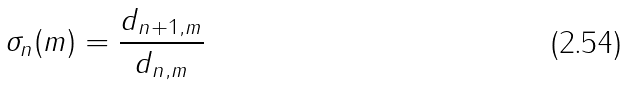Convert formula to latex. <formula><loc_0><loc_0><loc_500><loc_500>\sigma _ { n } ( m ) = \frac { d _ { n + 1 , m } } { d _ { n , m } }</formula> 